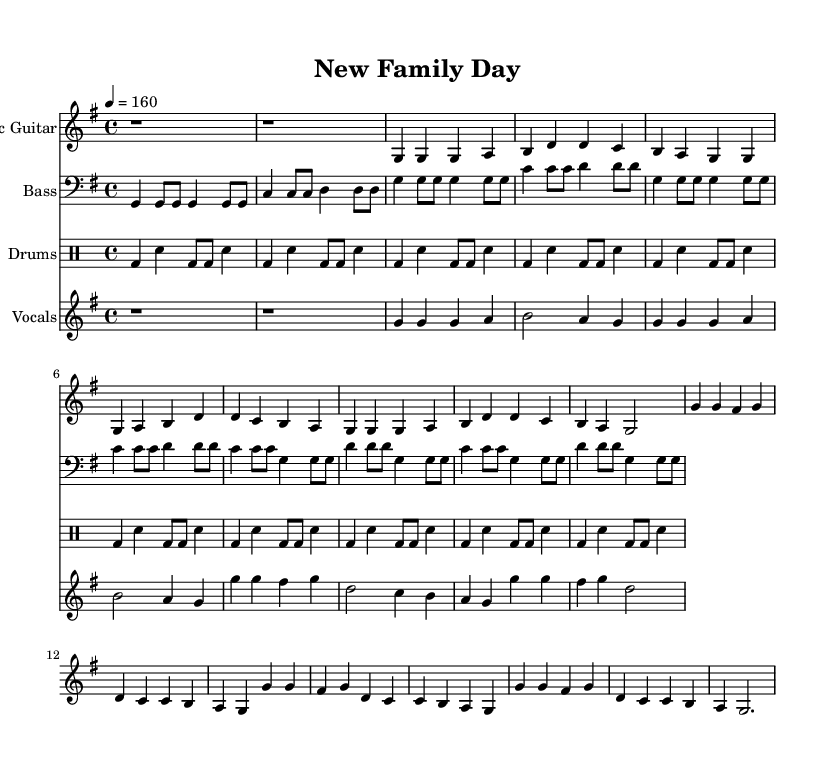What is the key signature of this music? The key signature is G major, which has one sharp (F#).
Answer: G major What is the time signature of the piece? The time signature is 4/4, indicating four beats per measure.
Answer: 4/4 What is the tempo marking for this piece? The tempo marking is quarter note equals 160 beats per minute, indicating a fast pace.
Answer: 160 How many measures are in the verse before the chorus starts? The verse contains 8 measures, as indicated by the repeated pattern in the music notation.
Answer: 8 What instruments are included in this arrangement? The arrangement includes electric guitar, bass, drums, and vocals, as each instrument is clearly labeled in the score.
Answer: Electric guitar, bass, drums, vocals What type of song structure does this piece display? This piece follows a verse-chorus structure, which is common in punk music that emphasizes melody and lyrics.
Answer: Verse-chorus What is the general mood conveyed by the lyrics? The lyrics convey a joyful and celebratory mood, focusing on themes of connection and new beginnings.
Answer: Joyful and celebratory 